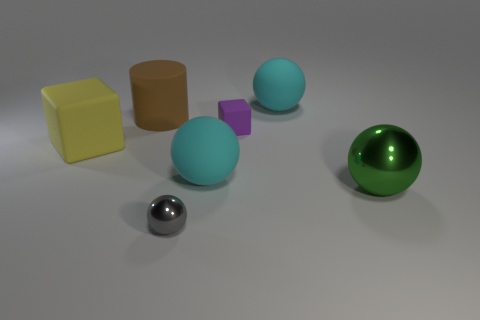Add 2 tiny gray metallic objects. How many objects exist? 9 Subtract all spheres. How many objects are left? 3 Add 6 big green objects. How many big green objects are left? 7 Add 4 tiny gray cubes. How many tiny gray cubes exist? 4 Subtract 0 red cylinders. How many objects are left? 7 Subtract all cyan objects. Subtract all cyan spheres. How many objects are left? 3 